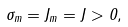Convert formula to latex. <formula><loc_0><loc_0><loc_500><loc_500>\sigma _ { m } = J _ { m } = J > 0 ,</formula> 